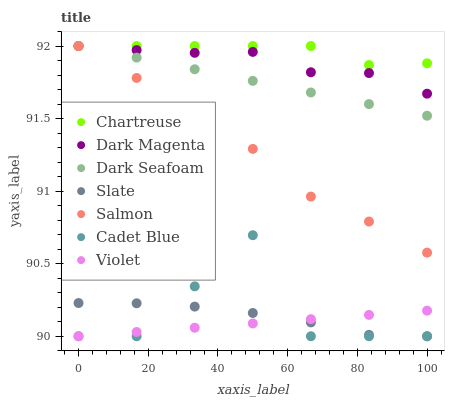Does Violet have the minimum area under the curve?
Answer yes or no. Yes. Does Chartreuse have the maximum area under the curve?
Answer yes or no. Yes. Does Dark Magenta have the minimum area under the curve?
Answer yes or no. No. Does Dark Magenta have the maximum area under the curve?
Answer yes or no. No. Is Violet the smoothest?
Answer yes or no. Yes. Is Cadet Blue the roughest?
Answer yes or no. Yes. Is Dark Magenta the smoothest?
Answer yes or no. No. Is Dark Magenta the roughest?
Answer yes or no. No. Does Cadet Blue have the lowest value?
Answer yes or no. Yes. Does Dark Magenta have the lowest value?
Answer yes or no. No. Does Chartreuse have the highest value?
Answer yes or no. Yes. Does Slate have the highest value?
Answer yes or no. No. Is Violet less than Dark Magenta?
Answer yes or no. Yes. Is Dark Magenta greater than Slate?
Answer yes or no. Yes. Does Chartreuse intersect Dark Seafoam?
Answer yes or no. Yes. Is Chartreuse less than Dark Seafoam?
Answer yes or no. No. Is Chartreuse greater than Dark Seafoam?
Answer yes or no. No. Does Violet intersect Dark Magenta?
Answer yes or no. No. 